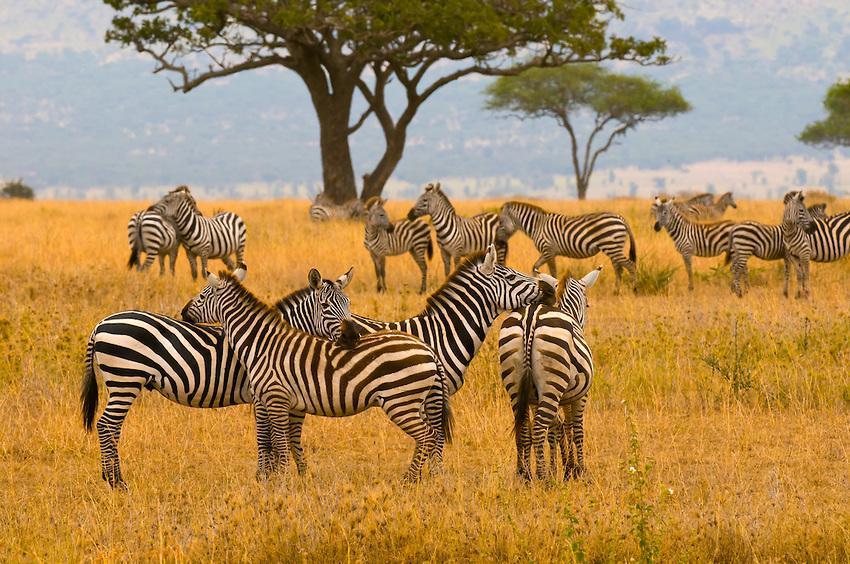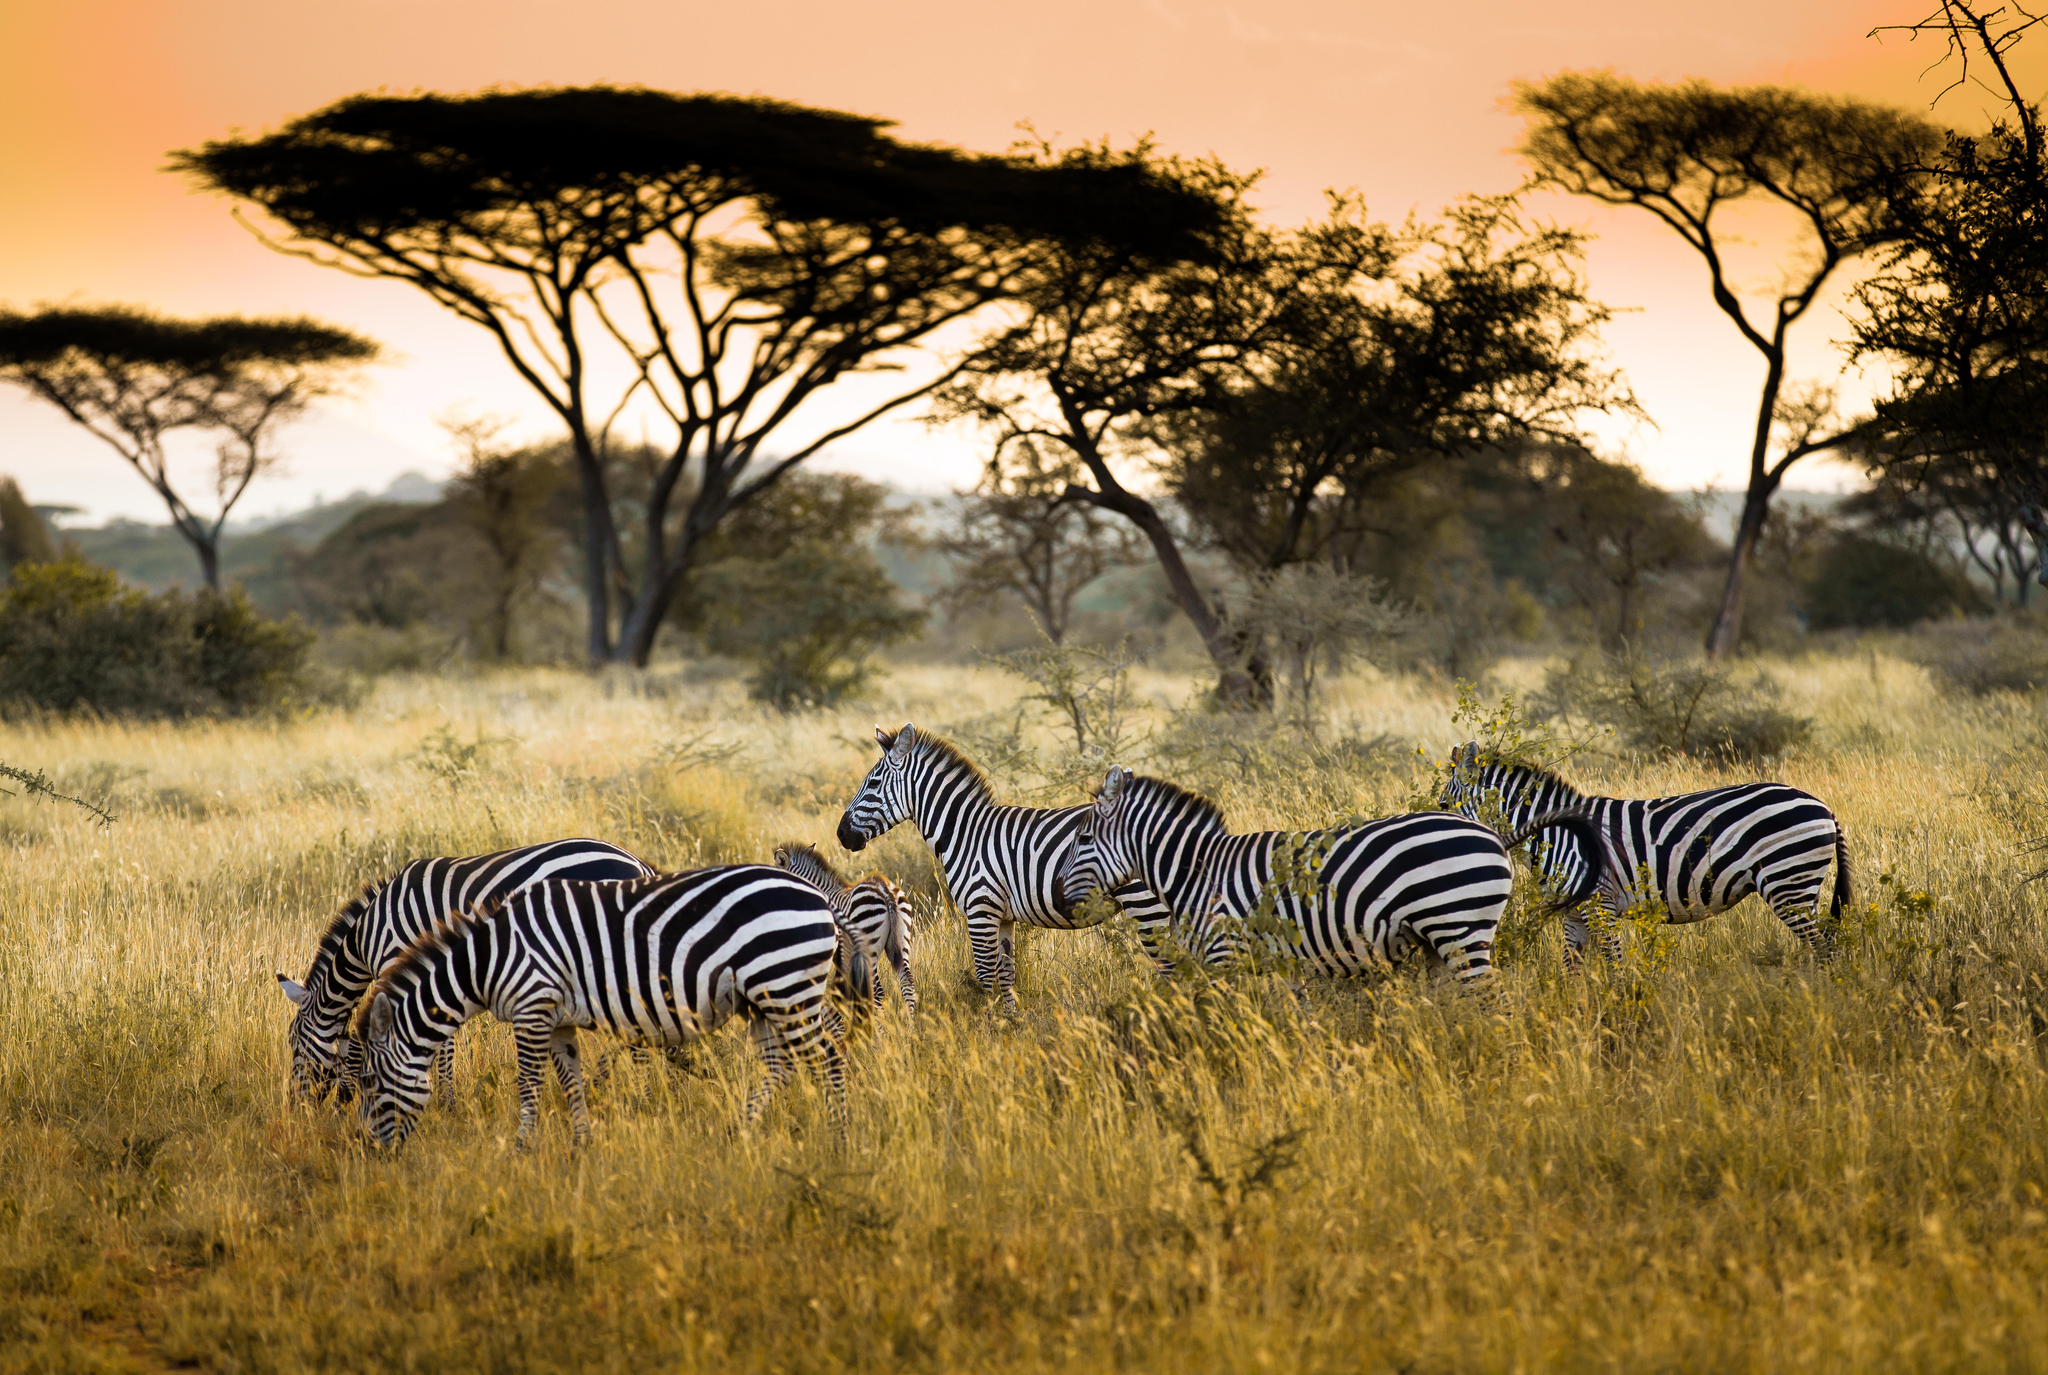The first image is the image on the left, the second image is the image on the right. Evaluate the accuracy of this statement regarding the images: "The right image contains no more than two zebras.". Is it true? Answer yes or no. No. The first image is the image on the left, the second image is the image on the right. Assess this claim about the two images: "One image shows a single zebra standing in profile with its head not bent to graze, and the other image shows a close cluster of zebras facing forward and backward.". Correct or not? Answer yes or no. No. 